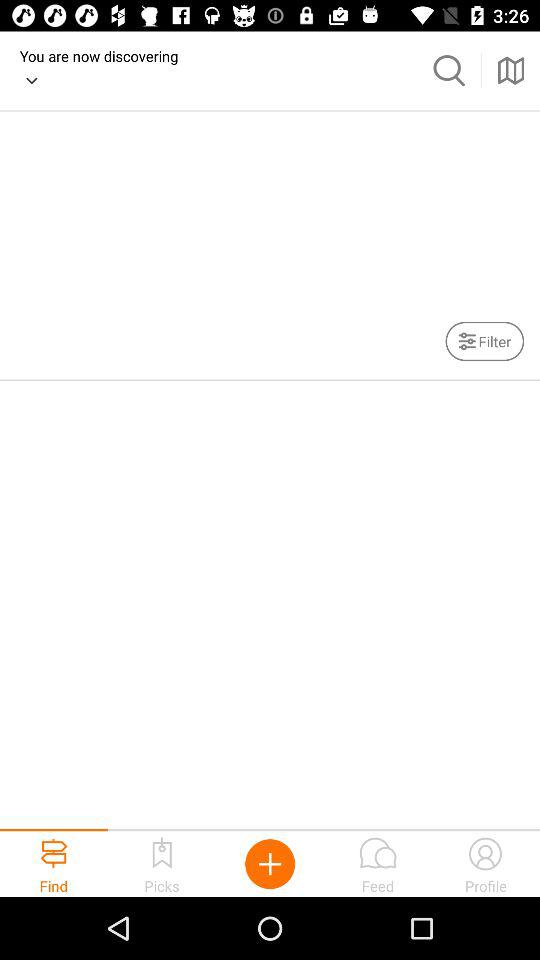What is the name of the user? The name of the user is Laura. 